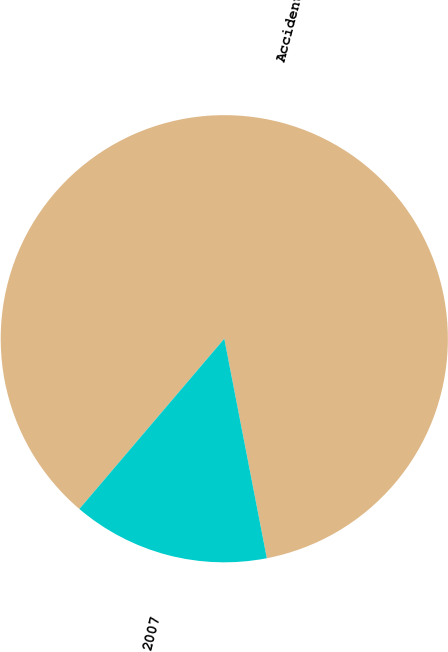Convert chart. <chart><loc_0><loc_0><loc_500><loc_500><pie_chart><fcel>Accident Year<fcel>2007<nl><fcel>85.73%<fcel>14.27%<nl></chart> 